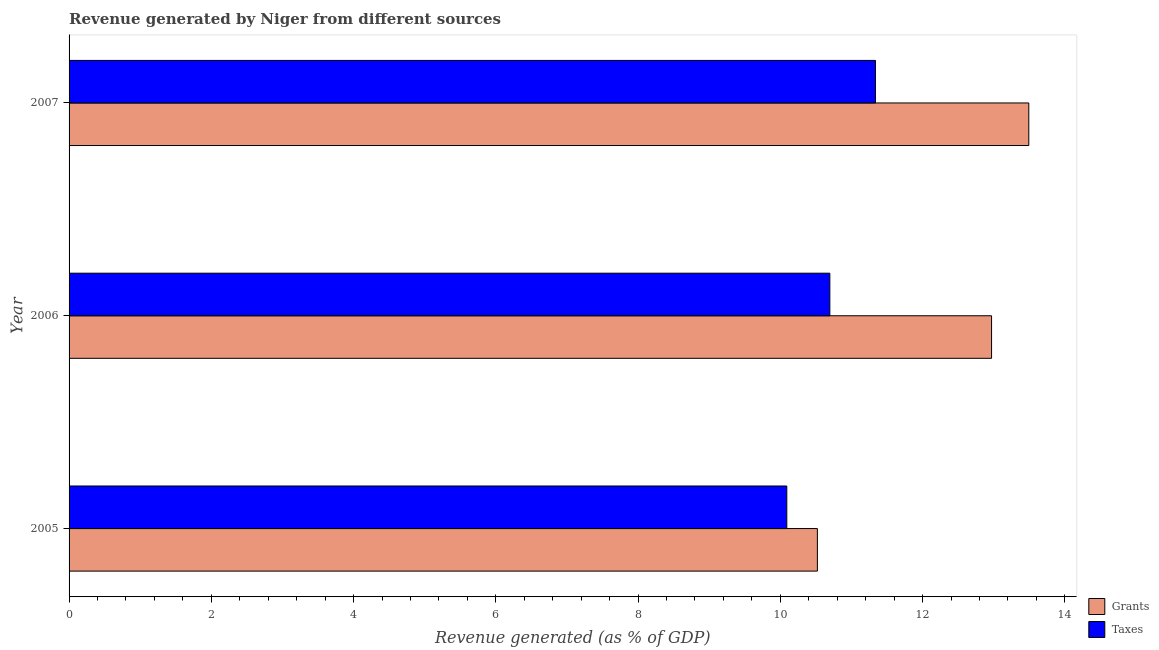How many different coloured bars are there?
Ensure brevity in your answer.  2. How many groups of bars are there?
Give a very brief answer. 3. Are the number of bars per tick equal to the number of legend labels?
Give a very brief answer. Yes. How many bars are there on the 2nd tick from the bottom?
Make the answer very short. 2. In how many cases, is the number of bars for a given year not equal to the number of legend labels?
Your answer should be compact. 0. What is the revenue generated by taxes in 2007?
Your answer should be very brief. 11.34. Across all years, what is the maximum revenue generated by taxes?
Offer a terse response. 11.34. Across all years, what is the minimum revenue generated by grants?
Keep it short and to the point. 10.52. In which year was the revenue generated by grants minimum?
Your answer should be very brief. 2005. What is the total revenue generated by grants in the graph?
Ensure brevity in your answer.  36.98. What is the difference between the revenue generated by grants in 2006 and that in 2007?
Make the answer very short. -0.52. What is the difference between the revenue generated by taxes in 2006 and the revenue generated by grants in 2005?
Provide a short and direct response. 0.17. What is the average revenue generated by taxes per year?
Your answer should be compact. 10.71. In the year 2006, what is the difference between the revenue generated by taxes and revenue generated by grants?
Your response must be concise. -2.27. What is the ratio of the revenue generated by grants in 2005 to that in 2007?
Offer a terse response. 0.78. Is the revenue generated by grants in 2006 less than that in 2007?
Provide a short and direct response. Yes. Is the difference between the revenue generated by grants in 2005 and 2006 greater than the difference between the revenue generated by taxes in 2005 and 2006?
Your answer should be compact. No. What is the difference between the highest and the second highest revenue generated by taxes?
Offer a terse response. 0.64. What is the difference between the highest and the lowest revenue generated by grants?
Your answer should be very brief. 2.97. In how many years, is the revenue generated by grants greater than the average revenue generated by grants taken over all years?
Give a very brief answer. 2. Is the sum of the revenue generated by grants in 2005 and 2007 greater than the maximum revenue generated by taxes across all years?
Make the answer very short. Yes. What does the 1st bar from the top in 2006 represents?
Your answer should be very brief. Taxes. What does the 1st bar from the bottom in 2005 represents?
Give a very brief answer. Grants. How many years are there in the graph?
Offer a very short reply. 3. What is the difference between two consecutive major ticks on the X-axis?
Provide a short and direct response. 2. Are the values on the major ticks of X-axis written in scientific E-notation?
Your answer should be compact. No. How many legend labels are there?
Your answer should be very brief. 2. What is the title of the graph?
Provide a short and direct response. Revenue generated by Niger from different sources. What is the label or title of the X-axis?
Provide a short and direct response. Revenue generated (as % of GDP). What is the Revenue generated (as % of GDP) in Grants in 2005?
Keep it short and to the point. 10.52. What is the Revenue generated (as % of GDP) in Taxes in 2005?
Your answer should be very brief. 10.09. What is the Revenue generated (as % of GDP) of Grants in 2006?
Make the answer very short. 12.97. What is the Revenue generated (as % of GDP) of Taxes in 2006?
Make the answer very short. 10.7. What is the Revenue generated (as % of GDP) in Grants in 2007?
Your answer should be compact. 13.49. What is the Revenue generated (as % of GDP) of Taxes in 2007?
Give a very brief answer. 11.34. Across all years, what is the maximum Revenue generated (as % of GDP) in Grants?
Your response must be concise. 13.49. Across all years, what is the maximum Revenue generated (as % of GDP) in Taxes?
Offer a terse response. 11.34. Across all years, what is the minimum Revenue generated (as % of GDP) of Grants?
Your response must be concise. 10.52. Across all years, what is the minimum Revenue generated (as % of GDP) in Taxes?
Provide a succinct answer. 10.09. What is the total Revenue generated (as % of GDP) in Grants in the graph?
Provide a short and direct response. 36.98. What is the total Revenue generated (as % of GDP) in Taxes in the graph?
Give a very brief answer. 32.12. What is the difference between the Revenue generated (as % of GDP) in Grants in 2005 and that in 2006?
Make the answer very short. -2.45. What is the difference between the Revenue generated (as % of GDP) of Taxes in 2005 and that in 2006?
Offer a very short reply. -0.61. What is the difference between the Revenue generated (as % of GDP) of Grants in 2005 and that in 2007?
Offer a very short reply. -2.97. What is the difference between the Revenue generated (as % of GDP) in Taxes in 2005 and that in 2007?
Give a very brief answer. -1.25. What is the difference between the Revenue generated (as % of GDP) in Grants in 2006 and that in 2007?
Offer a very short reply. -0.52. What is the difference between the Revenue generated (as % of GDP) of Taxes in 2006 and that in 2007?
Make the answer very short. -0.64. What is the difference between the Revenue generated (as % of GDP) of Grants in 2005 and the Revenue generated (as % of GDP) of Taxes in 2006?
Give a very brief answer. -0.17. What is the difference between the Revenue generated (as % of GDP) of Grants in 2005 and the Revenue generated (as % of GDP) of Taxes in 2007?
Provide a short and direct response. -0.82. What is the difference between the Revenue generated (as % of GDP) in Grants in 2006 and the Revenue generated (as % of GDP) in Taxes in 2007?
Your response must be concise. 1.63. What is the average Revenue generated (as % of GDP) in Grants per year?
Provide a succinct answer. 12.33. What is the average Revenue generated (as % of GDP) in Taxes per year?
Give a very brief answer. 10.71. In the year 2005, what is the difference between the Revenue generated (as % of GDP) of Grants and Revenue generated (as % of GDP) of Taxes?
Offer a very short reply. 0.43. In the year 2006, what is the difference between the Revenue generated (as % of GDP) of Grants and Revenue generated (as % of GDP) of Taxes?
Your answer should be very brief. 2.27. In the year 2007, what is the difference between the Revenue generated (as % of GDP) of Grants and Revenue generated (as % of GDP) of Taxes?
Your response must be concise. 2.16. What is the ratio of the Revenue generated (as % of GDP) in Grants in 2005 to that in 2006?
Offer a very short reply. 0.81. What is the ratio of the Revenue generated (as % of GDP) in Taxes in 2005 to that in 2006?
Your response must be concise. 0.94. What is the ratio of the Revenue generated (as % of GDP) in Grants in 2005 to that in 2007?
Provide a succinct answer. 0.78. What is the ratio of the Revenue generated (as % of GDP) in Taxes in 2005 to that in 2007?
Your answer should be compact. 0.89. What is the ratio of the Revenue generated (as % of GDP) of Grants in 2006 to that in 2007?
Provide a succinct answer. 0.96. What is the ratio of the Revenue generated (as % of GDP) in Taxes in 2006 to that in 2007?
Make the answer very short. 0.94. What is the difference between the highest and the second highest Revenue generated (as % of GDP) of Grants?
Offer a terse response. 0.52. What is the difference between the highest and the second highest Revenue generated (as % of GDP) in Taxes?
Offer a very short reply. 0.64. What is the difference between the highest and the lowest Revenue generated (as % of GDP) of Grants?
Your answer should be compact. 2.97. What is the difference between the highest and the lowest Revenue generated (as % of GDP) in Taxes?
Offer a terse response. 1.25. 